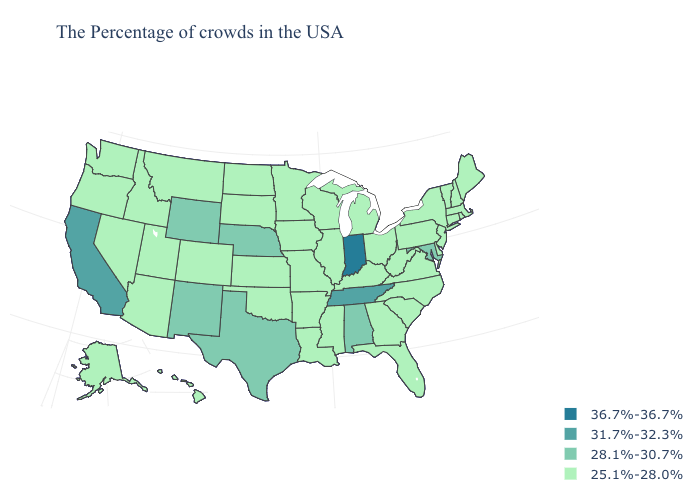Is the legend a continuous bar?
Answer briefly. No. Which states have the lowest value in the MidWest?
Keep it brief. Ohio, Michigan, Wisconsin, Illinois, Missouri, Minnesota, Iowa, Kansas, South Dakota, North Dakota. Name the states that have a value in the range 31.7%-32.3%?
Keep it brief. Tennessee, California. What is the lowest value in states that border Rhode Island?
Answer briefly. 25.1%-28.0%. Does South Carolina have the lowest value in the USA?
Write a very short answer. Yes. Name the states that have a value in the range 31.7%-32.3%?
Answer briefly. Tennessee, California. Name the states that have a value in the range 25.1%-28.0%?
Answer briefly. Maine, Massachusetts, Rhode Island, New Hampshire, Vermont, Connecticut, New York, New Jersey, Delaware, Pennsylvania, Virginia, North Carolina, South Carolina, West Virginia, Ohio, Florida, Georgia, Michigan, Kentucky, Wisconsin, Illinois, Mississippi, Louisiana, Missouri, Arkansas, Minnesota, Iowa, Kansas, Oklahoma, South Dakota, North Dakota, Colorado, Utah, Montana, Arizona, Idaho, Nevada, Washington, Oregon, Alaska, Hawaii. Name the states that have a value in the range 25.1%-28.0%?
Give a very brief answer. Maine, Massachusetts, Rhode Island, New Hampshire, Vermont, Connecticut, New York, New Jersey, Delaware, Pennsylvania, Virginia, North Carolina, South Carolina, West Virginia, Ohio, Florida, Georgia, Michigan, Kentucky, Wisconsin, Illinois, Mississippi, Louisiana, Missouri, Arkansas, Minnesota, Iowa, Kansas, Oklahoma, South Dakota, North Dakota, Colorado, Utah, Montana, Arizona, Idaho, Nevada, Washington, Oregon, Alaska, Hawaii. What is the value of Louisiana?
Quick response, please. 25.1%-28.0%. Among the states that border Ohio , does Indiana have the lowest value?
Answer briefly. No. Which states hav the highest value in the MidWest?
Write a very short answer. Indiana. Name the states that have a value in the range 28.1%-30.7%?
Short answer required. Maryland, Alabama, Nebraska, Texas, Wyoming, New Mexico. Name the states that have a value in the range 31.7%-32.3%?
Short answer required. Tennessee, California. Name the states that have a value in the range 28.1%-30.7%?
Keep it brief. Maryland, Alabama, Nebraska, Texas, Wyoming, New Mexico. 